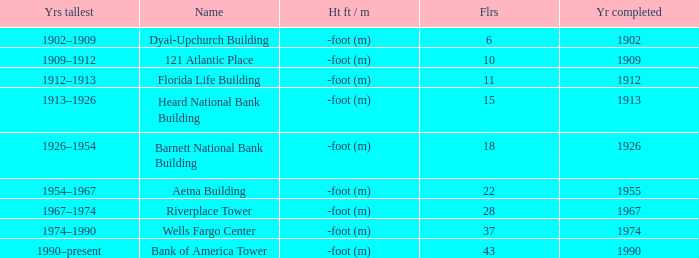Could you parse the entire table as a dict? {'header': ['Yrs tallest', 'Name', 'Ht ft / m', 'Flrs', 'Yr completed'], 'rows': [['1902–1909', 'Dyal-Upchurch Building', '-foot (m)', '6', '1902'], ['1909–1912', '121 Atlantic Place', '-foot (m)', '10', '1909'], ['1912–1913', 'Florida Life Building', '-foot (m)', '11', '1912'], ['1913–1926', 'Heard National Bank Building', '-foot (m)', '15', '1913'], ['1926–1954', 'Barnett National Bank Building', '-foot (m)', '18', '1926'], ['1954–1967', 'Aetna Building', '-foot (m)', '22', '1955'], ['1967–1974', 'Riverplace Tower', '-foot (m)', '28', '1967'], ['1974–1990', 'Wells Fargo Center', '-foot (m)', '37', '1974'], ['1990–present', 'Bank of America Tower', '-foot (m)', '43', '1990']]} What was the name of the building with 10 floors? 121 Atlantic Place. 